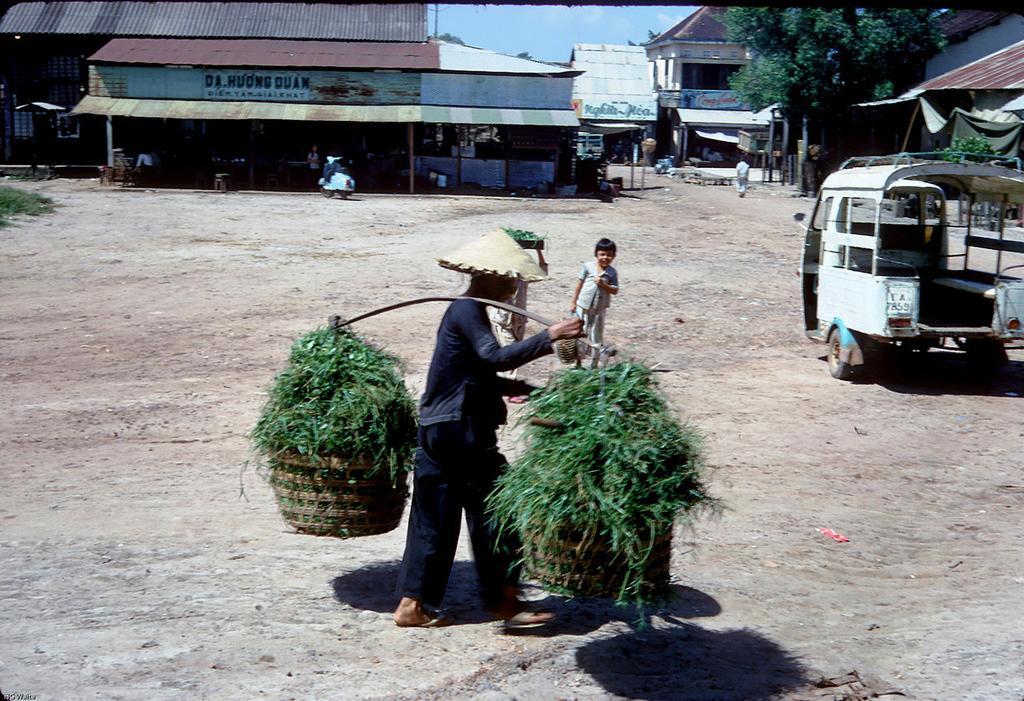Please provide a concise description of this image. In this image we can see a man is walking, he is carrying two pots on his shoulder. Behind him one girl is standing. Right side of the image one vehicle is present. Background of the image buildings are there and one tree is present. 